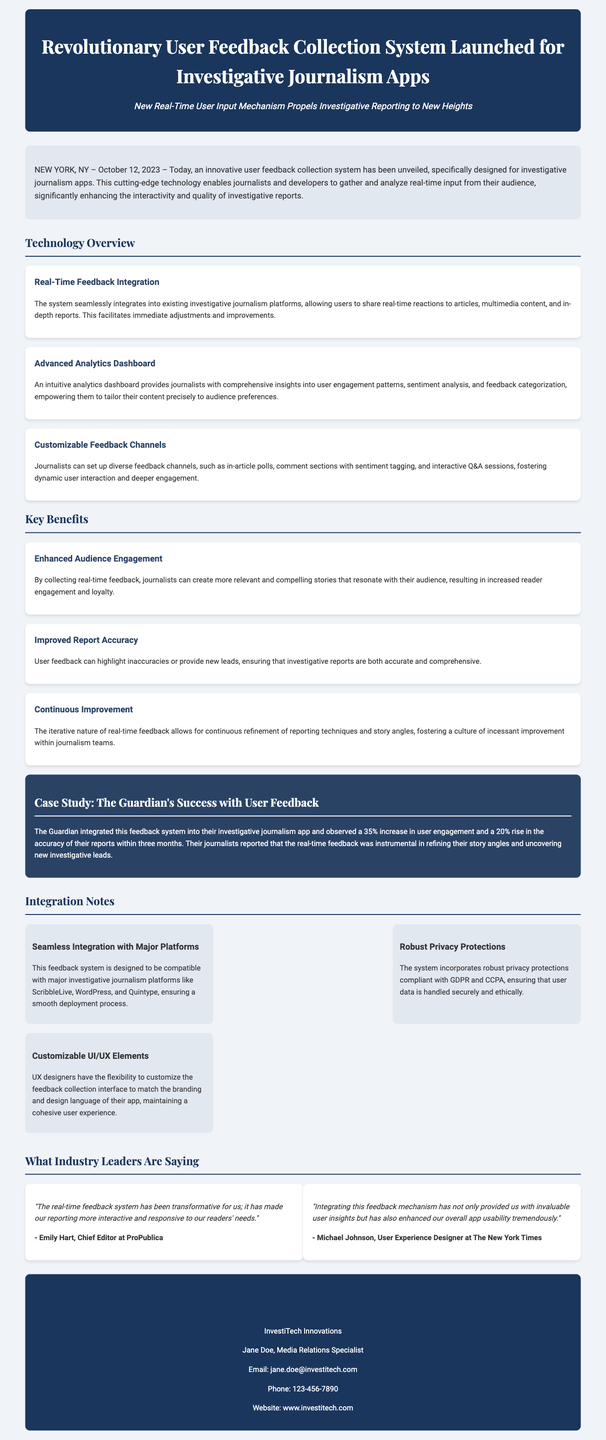What is the launch date of the user feedback collection system? The launch date mentioned in the document is October 12, 2023.
Answer: October 12, 2023 What is the name of the company that unveiled the feedback system? The company that unveiled the feedback system is named InvestiTech Innovations.
Answer: InvestiTech Innovations What percentage increase in user engagement did The Guardian observe? The Guardian observed a 35% increase in user engagement.
Answer: 35% What are the major platforms compatible with the feedback system? The feedback system is compatible with ScribbleLive, WordPress, and Quintype.
Answer: ScribbleLive, WordPress, and Quintype Who is the Chief Editor at ProPublica? According to the document, the Chief Editor at ProPublica is Emily Hart.
Answer: Emily Hart What is one of the customizable elements mentioned for the feedback system? One of the customizable elements is the feedback collection interface.
Answer: Feedback collection interface Why is the feedback system considered transformative by industry leaders? It is considered transformative because it has made reporting more interactive and responsive.
Answer: Interactive and responsive What key benefit is associated with the continuous collection of user feedback? A key benefit associated with continuous feedback is the improvement of report accuracy.
Answer: Improved report accuracy 